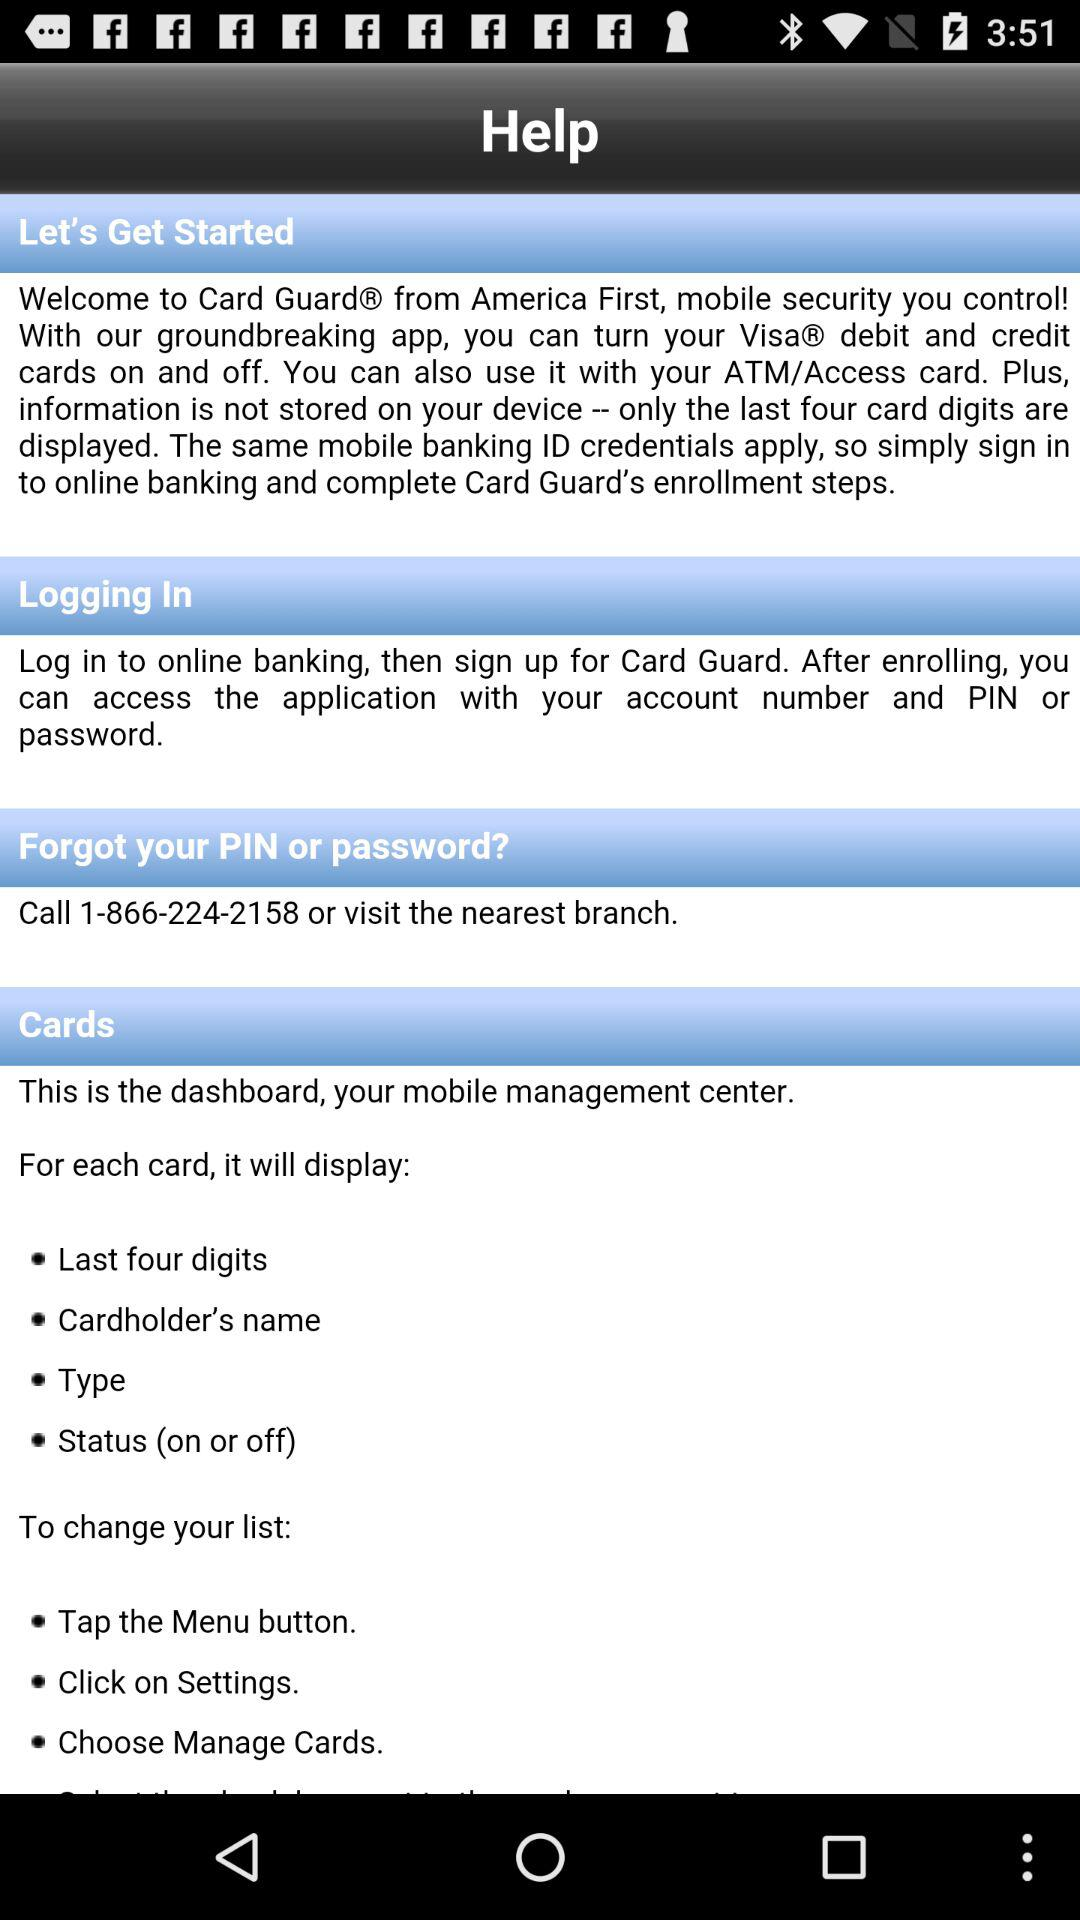Which things will display on cards? The things will be "Last four digits" "Cardholder's name", "Type", and "Status (on or off)". 